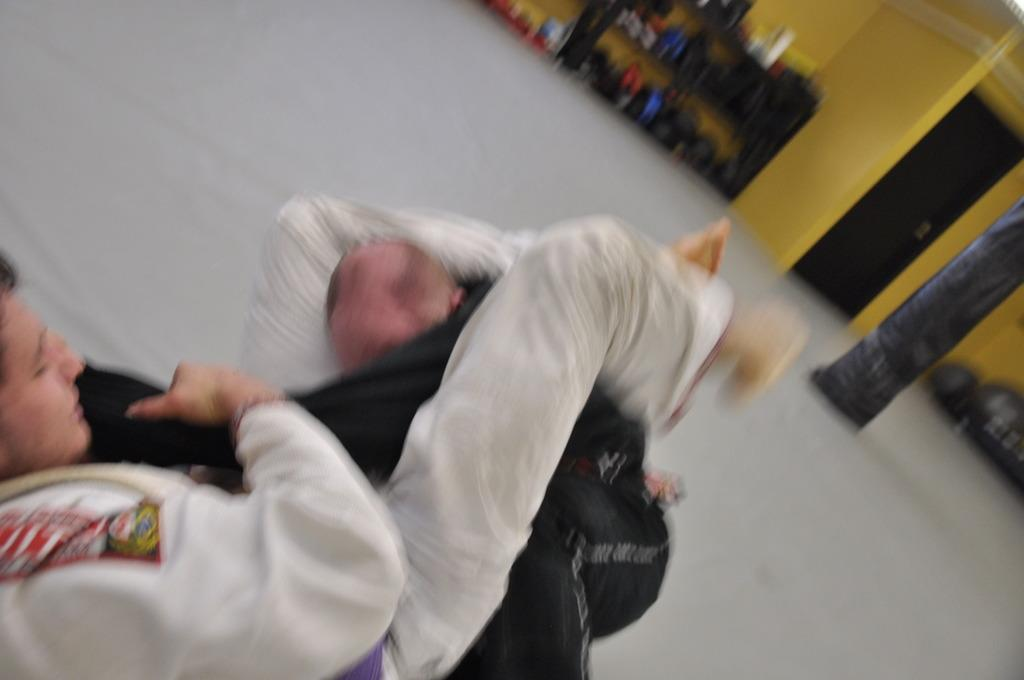How many people are visible on the path in the image? There are two people on the path in the image. What is the appearance of the people in the image? The people are blurred in the image. What can be seen behind the people in the image? There are blurred objects behind the people in the image. What is the color of the wall with a door in the image? The wall with a door is yellow in the image. What type of cheese is being grated by the person on the left in the image? There is no person grating cheese in the image; the people are blurred and no cheese is present. What sound does the horn make in the image? There is no horn present in the image, so it is not possible to determine the sound it would make. 